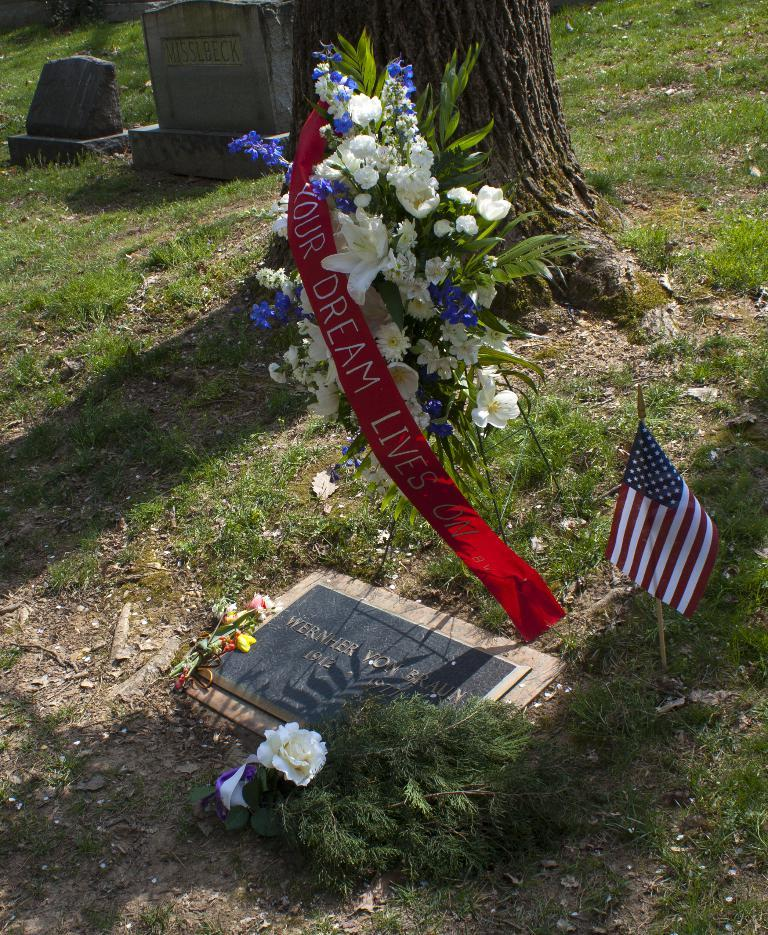What is the main object in the image? There is a gravestone in the image. What can be found on the gravestone? There is text on the gravestone. What other objects are nearby the gravestone? There is a book nearby the gravestone. What additional items can be seen in the image? There is a flag, flowers, and a badge in the image. What can be seen in the background of the image? There is grassland, a tree, and stones in the background of the image. Can you see a gun being held by someone in the image? No, there is no gun or person holding a gun in the image. Is there a tent visible in the background of the image? No, there is no tent present in the image. 